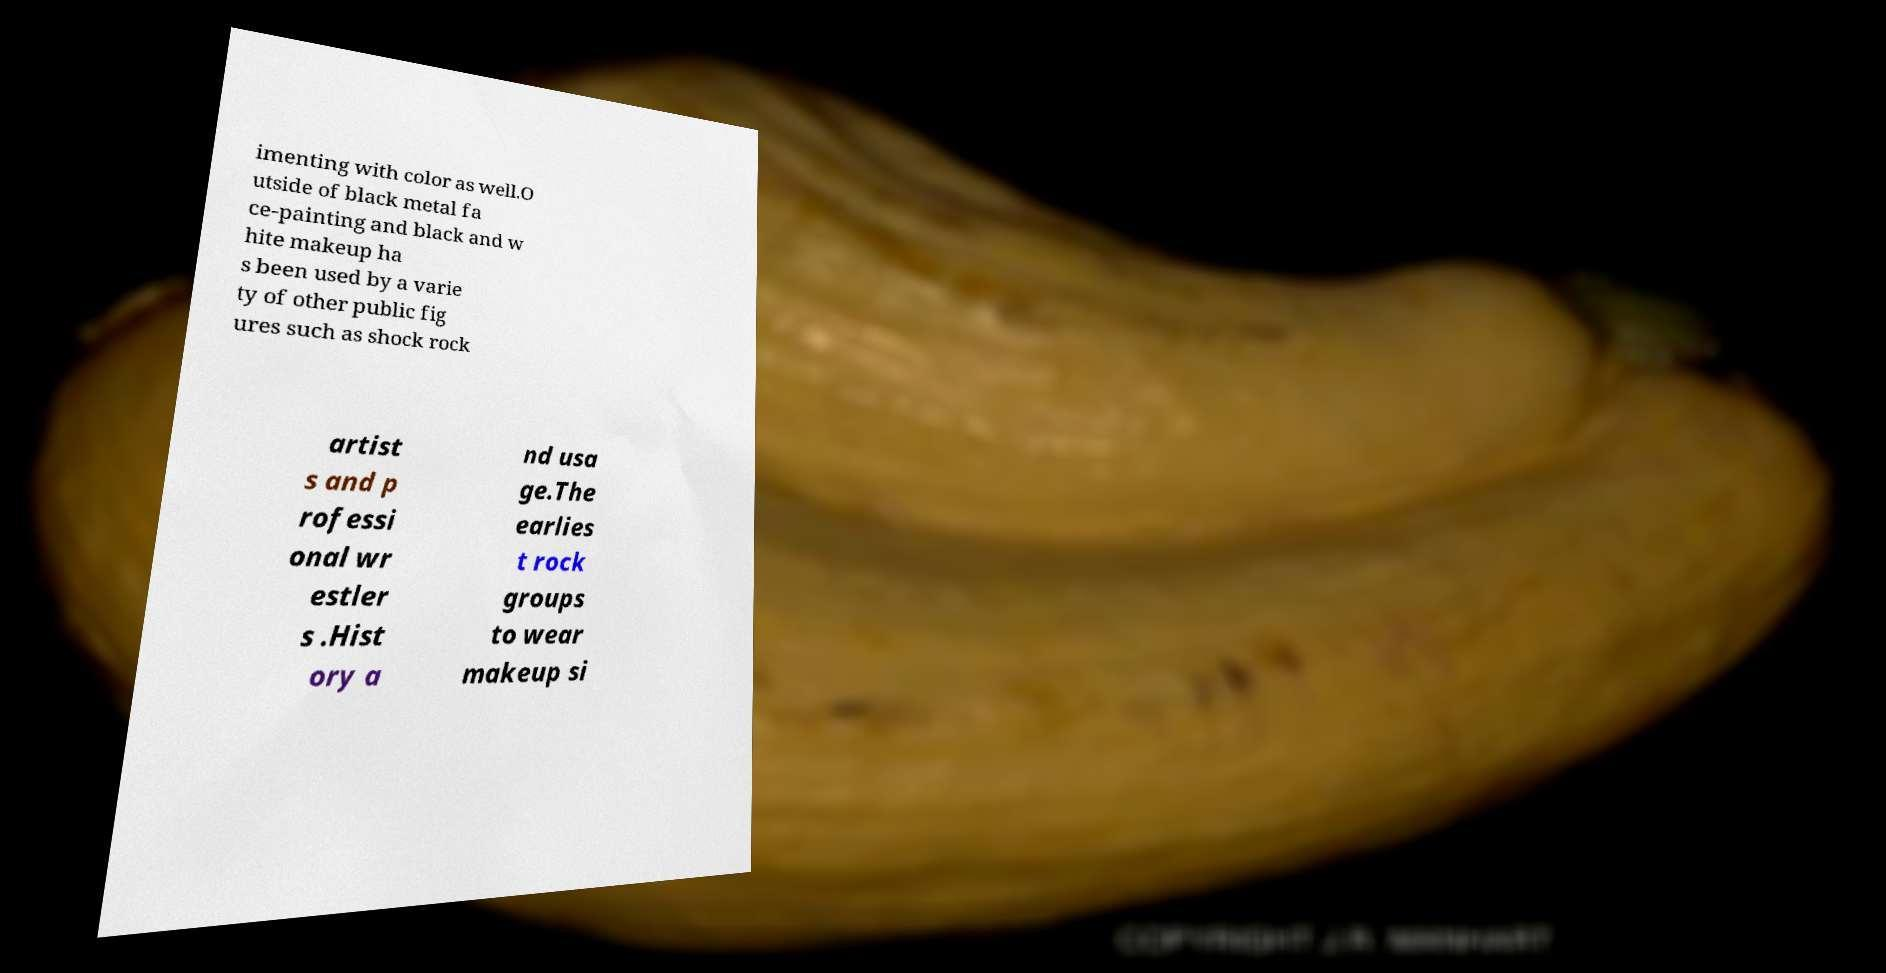For documentation purposes, I need the text within this image transcribed. Could you provide that? imenting with color as well.O utside of black metal fa ce-painting and black and w hite makeup ha s been used by a varie ty of other public fig ures such as shock rock artist s and p rofessi onal wr estler s .Hist ory a nd usa ge.The earlies t rock groups to wear makeup si 